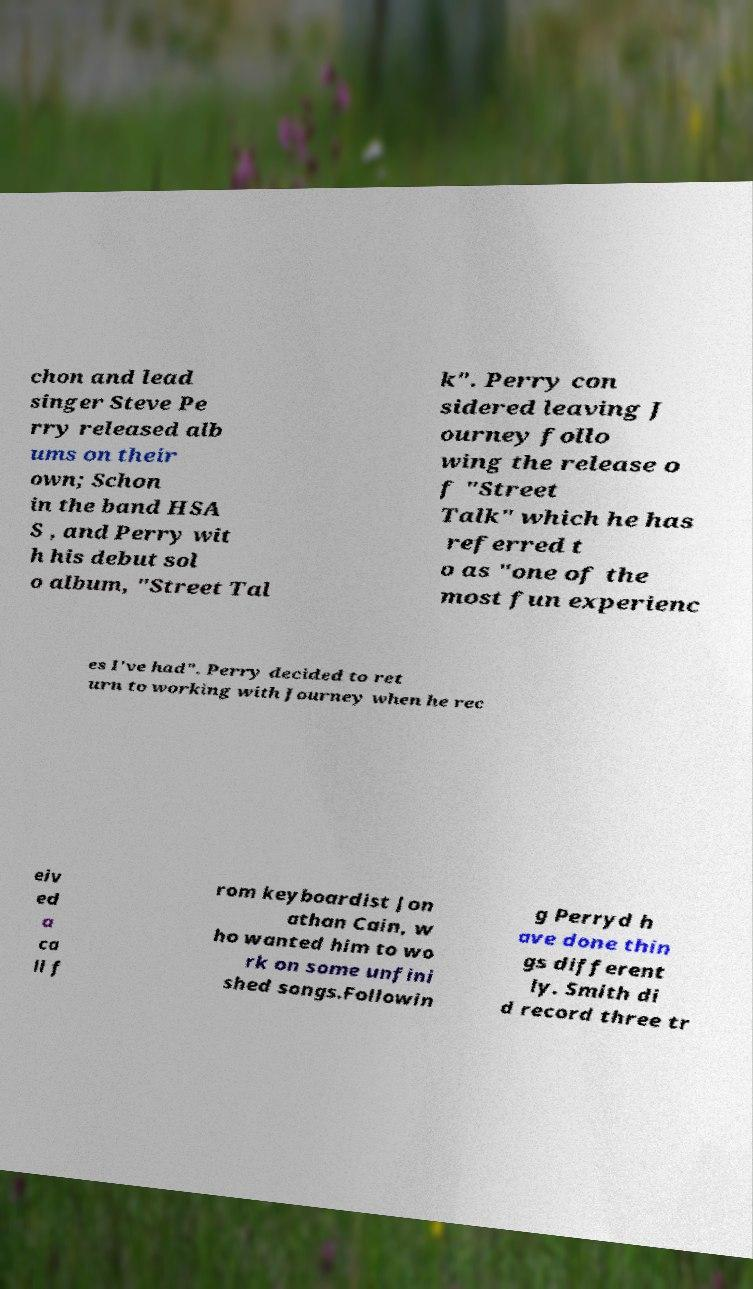What messages or text are displayed in this image? I need them in a readable, typed format. chon and lead singer Steve Pe rry released alb ums on their own; Schon in the band HSA S , and Perry wit h his debut sol o album, "Street Tal k". Perry con sidered leaving J ourney follo wing the release o f "Street Talk" which he has referred t o as "one of the most fun experienc es I've had". Perry decided to ret urn to working with Journey when he rec eiv ed a ca ll f rom keyboardist Jon athan Cain, w ho wanted him to wo rk on some unfini shed songs.Followin g Perryd h ave done thin gs different ly. Smith di d record three tr 